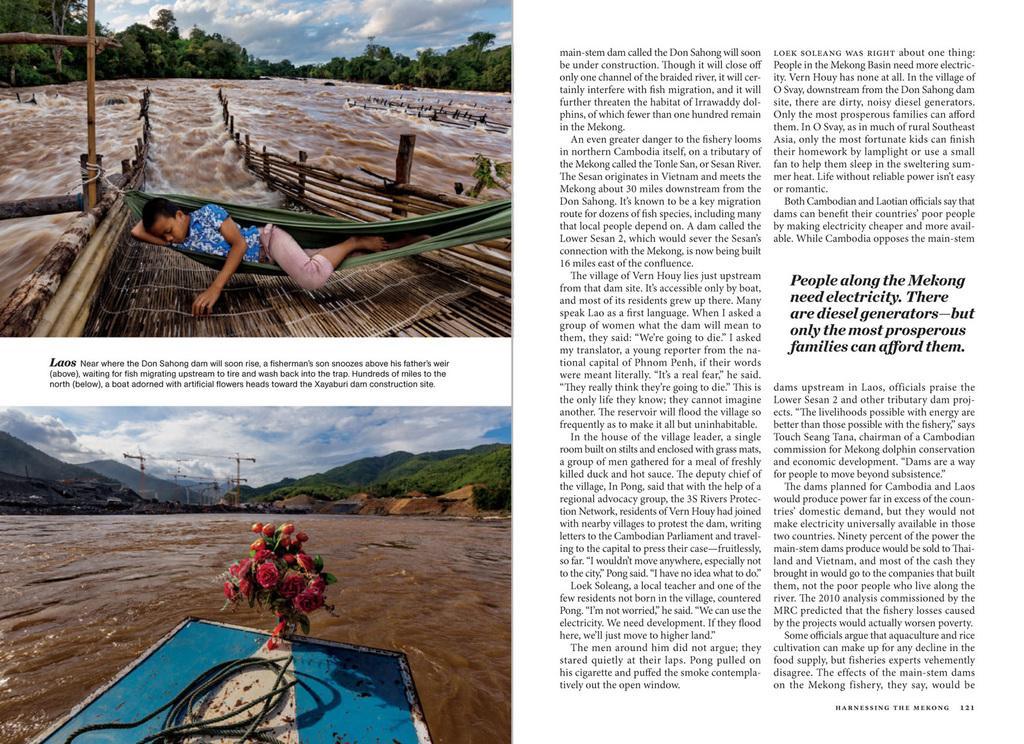Describe this image in one or two sentences. This is the picture of a paper on which there are two images and some things written on it. 